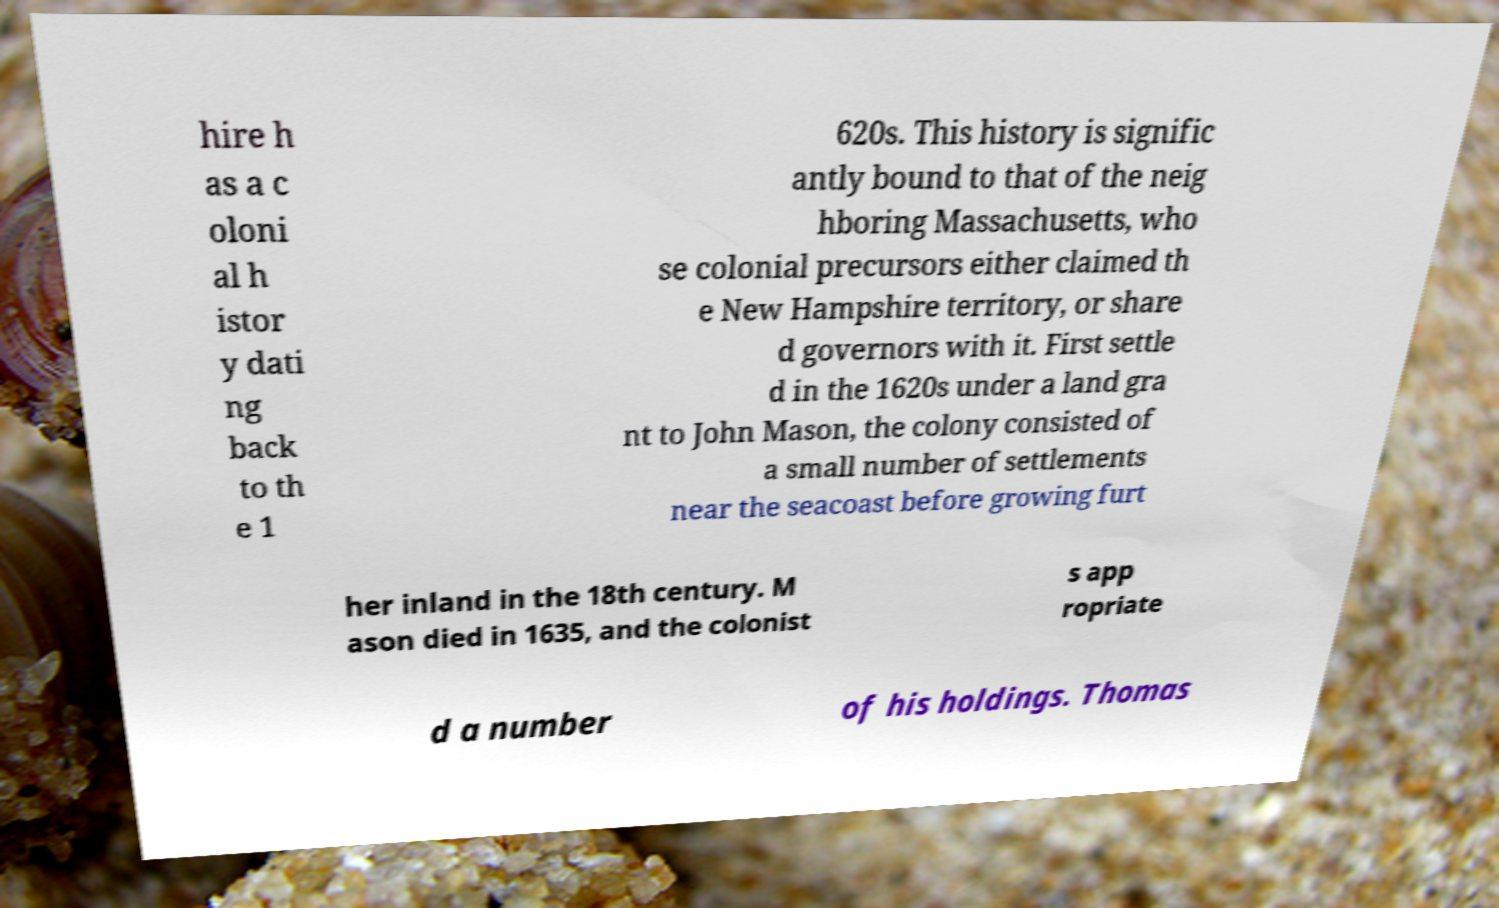For documentation purposes, I need the text within this image transcribed. Could you provide that? hire h as a c oloni al h istor y dati ng back to th e 1 620s. This history is signific antly bound to that of the neig hboring Massachusetts, who se colonial precursors either claimed th e New Hampshire territory, or share d governors with it. First settle d in the 1620s under a land gra nt to John Mason, the colony consisted of a small number of settlements near the seacoast before growing furt her inland in the 18th century. M ason died in 1635, and the colonist s app ropriate d a number of his holdings. Thomas 